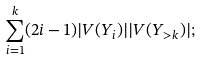<formula> <loc_0><loc_0><loc_500><loc_500>\sum _ { i = 1 } ^ { k } ( 2 i - 1 ) | V ( Y _ { i } ) | | V ( Y _ { > k } ) | ;</formula> 